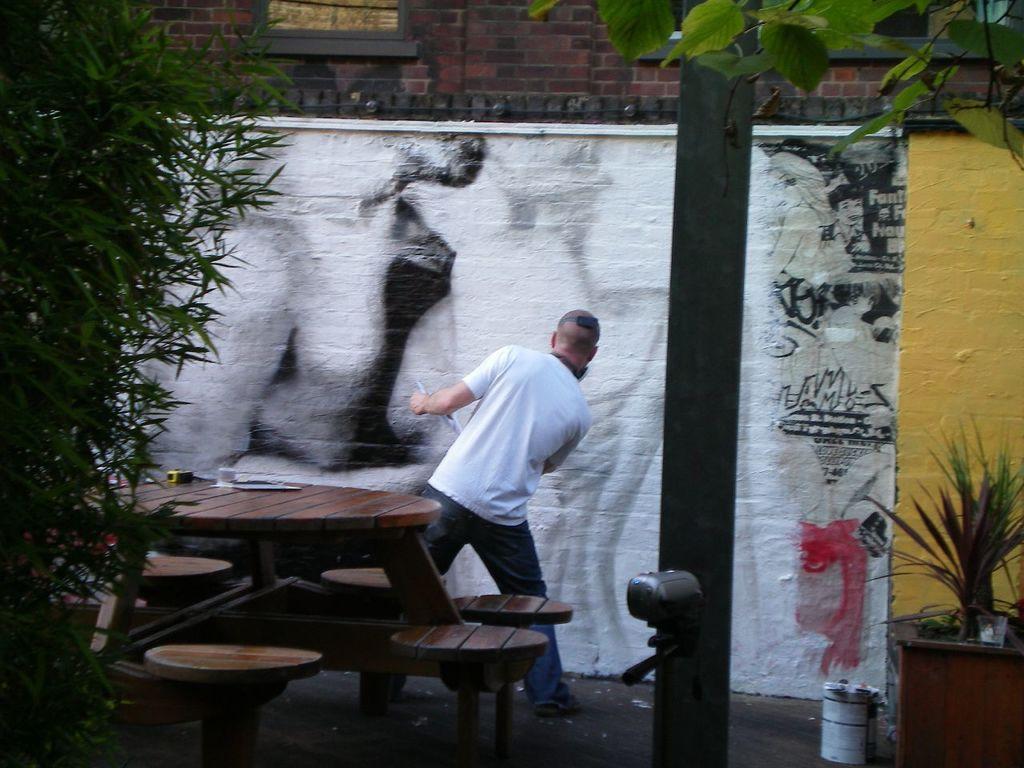Can you describe this image briefly? Around this table there are chairs. This person wore white t-shirt and standing. This is building with window. We can able to see plants and tree. A painting on wall. 